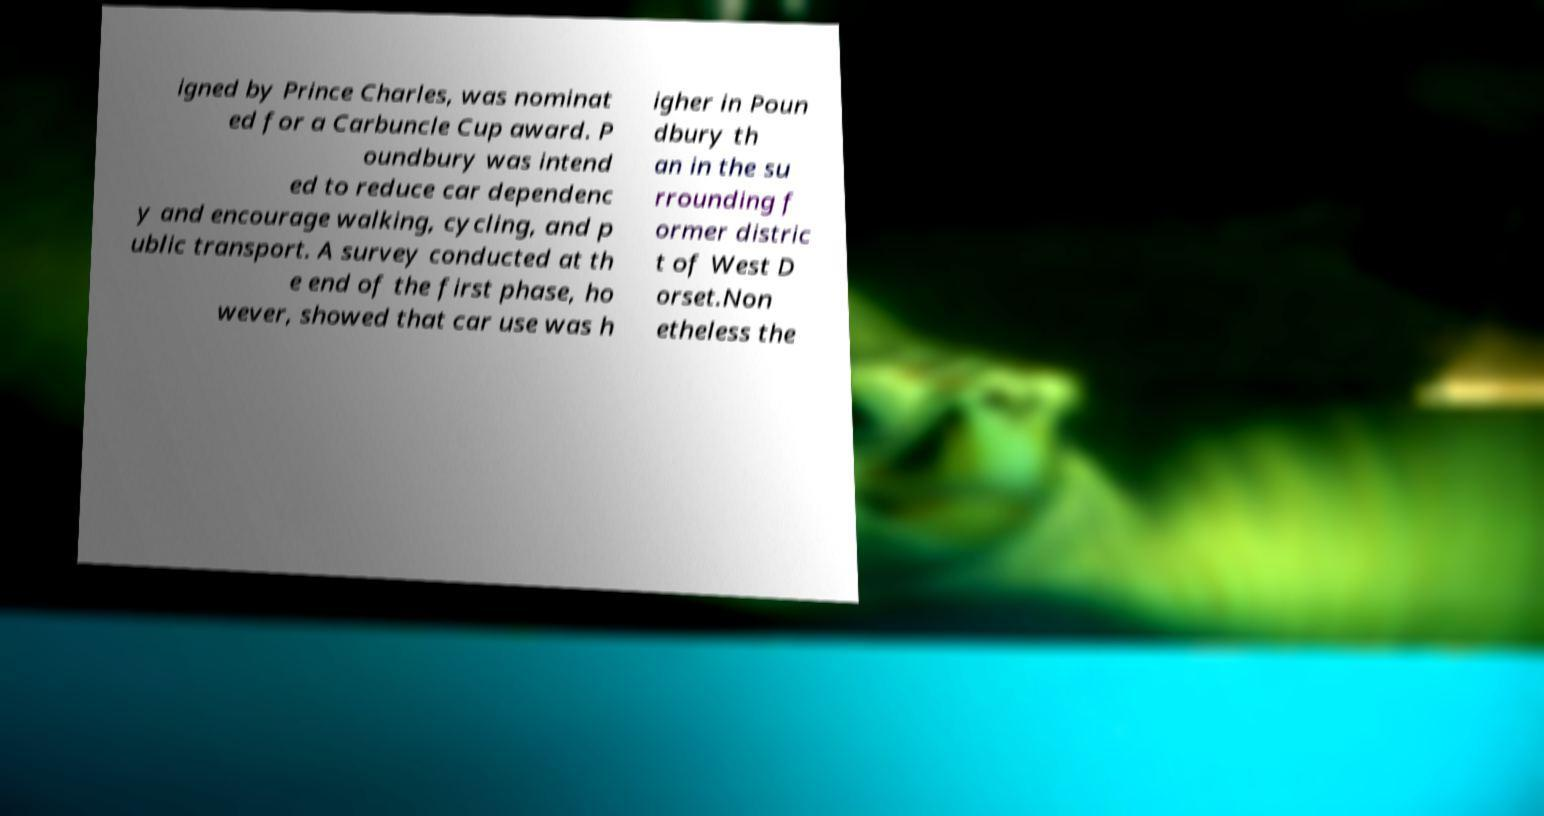I need the written content from this picture converted into text. Can you do that? igned by Prince Charles, was nominat ed for a Carbuncle Cup award. P oundbury was intend ed to reduce car dependenc y and encourage walking, cycling, and p ublic transport. A survey conducted at th e end of the first phase, ho wever, showed that car use was h igher in Poun dbury th an in the su rrounding f ormer distric t of West D orset.Non etheless the 